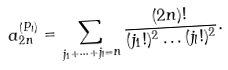Convert formula to latex. <formula><loc_0><loc_0><loc_500><loc_500>a _ { 2 n } ^ { ( P _ { l } ) } = \sum _ { j _ { 1 } + \dots + j _ { l } = n } \frac { ( 2 n ) ! } { ( j _ { 1 } ! ) ^ { 2 } \dots ( j _ { l } ! ) ^ { 2 } } .</formula> 